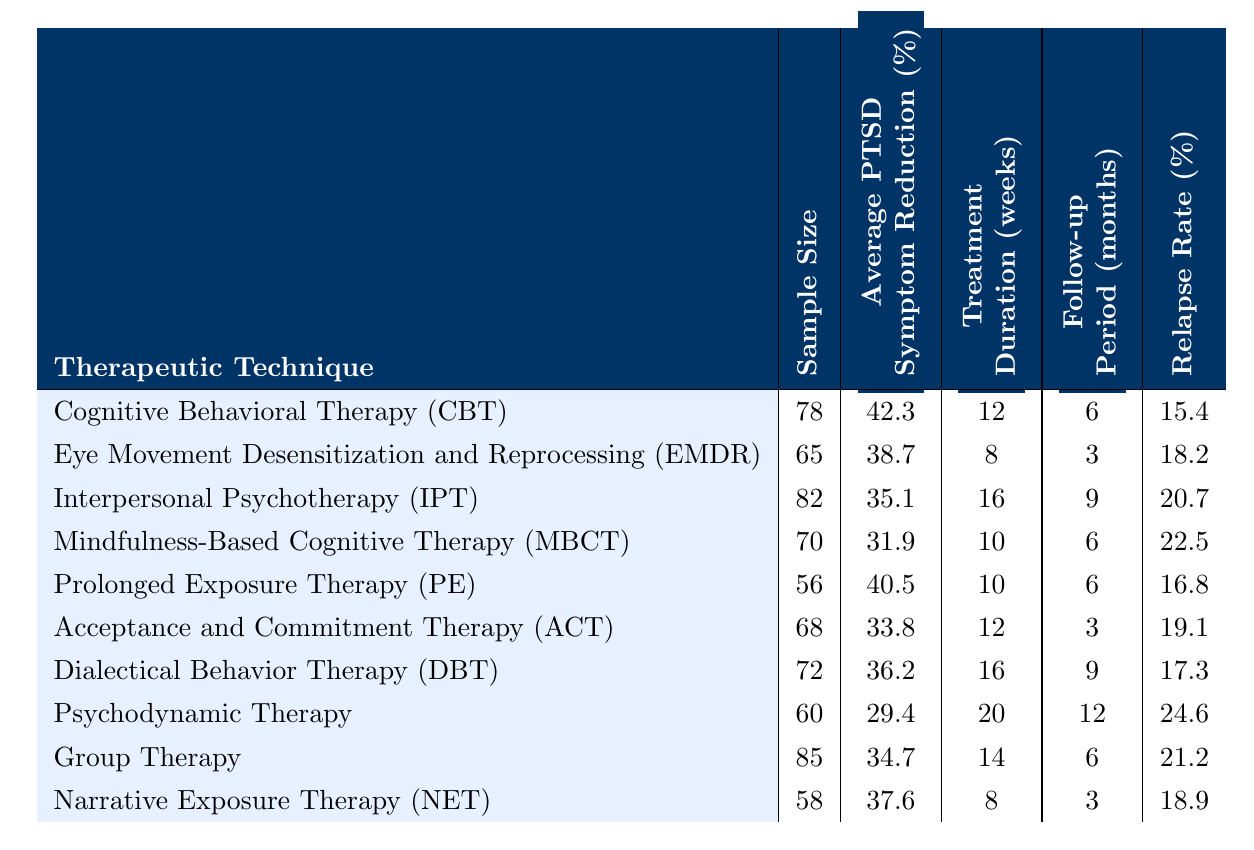What is the average PTSD symptom reduction for Cognitive Behavioral Therapy (CBT)? The table shows that the average PTSD symptom reduction for CBT is listed as 42.3%.
Answer: 42.3% Which therapeutic technique has the highest average PTSD symptom reduction? By comparing the average PTSD symptom reductions in the table, CBT has the highest reduction at 42.3%.
Answer: CBT What is the sample size for Prolonged Exposure Therapy (PE)? The table indicates that the sample size for PE is 56 participants.
Answer: 56 What is the treatment duration for Interpersonal Psychotherapy (IPT)? According to the table, IPT has a treatment duration of 16 weeks.
Answer: 16 weeks What is the relapse rate for Narrative Exposure Therapy (NET)? The table states that the relapse rate for NET is 18.9%.
Answer: 18.9% Which therapeutic technique has the lowest relapse rate? By looking at the listed relapse rates, Psychodynamic Therapy has the lowest at 24.6%.
Answer: Psychodynamic Therapy What is the average PTSD symptom reduction across all therapies listed? To find the average, sum the average reductions (42.3 + 38.7 + 35.1 + 31.9 + 40.5 + 33.8 + 36.2 + 29.4 + 34.7 + 37.6 =  388.8) and divide by the number of techniques (10): 388.8/10 = 38.88%.
Answer: 38.88% If a mother underwent Mindfulness-Based Cognitive Therapy (MBCT), how long are the treatment duration and follow-up period in total? The treatment duration for MBCT is 10 weeks and the follow-up period is 6 months. Adding them together gives a total of 10 + 6 = 16 weeks.
Answer: 16 weeks What is the difference in average PTSD symptom reduction between Prolonged Exposure Therapy (PE) and Eye Movement Desensitization and Reprocessing (EMDR)? The average reduction for PE is 40.5% and for EMDR is 38.7%. The difference is 40.5 - 38.7 = 1.8%.
Answer: 1.8% Does Acceptance and Commitment Therapy (ACT) have a higher average PTSD symptom reduction than Psychodynamic Therapy? The average reduction for ACT is 33.8% and for Psychodynamic Therapy is 29.4%. Since 33.8% is greater than 29.4%, the answer is true.
Answer: Yes 